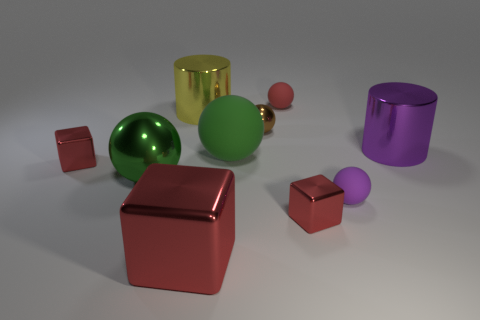Do the big metallic ball and the large ball on the right side of the big red thing have the same color?
Make the answer very short. Yes. There is a yellow metallic cylinder; how many tiny metallic cubes are to the right of it?
Ensure brevity in your answer.  1. Are there fewer big green spheres that are on the right side of the big block than big cubes?
Offer a very short reply. No. What is the color of the big metal ball?
Provide a short and direct response. Green. There is a tiny shiny block on the left side of the tiny red matte object; is its color the same as the large shiny cube?
Ensure brevity in your answer.  Yes. What is the color of the other tiny rubber object that is the same shape as the purple rubber object?
Your answer should be very brief. Red. How many tiny things are either yellow cylinders or green cylinders?
Keep it short and to the point. 0. How big is the thing to the left of the green metallic object?
Provide a succinct answer. Small. Is there a object of the same color as the large shiny ball?
Provide a short and direct response. Yes. Does the big shiny sphere have the same color as the big matte thing?
Ensure brevity in your answer.  Yes. 